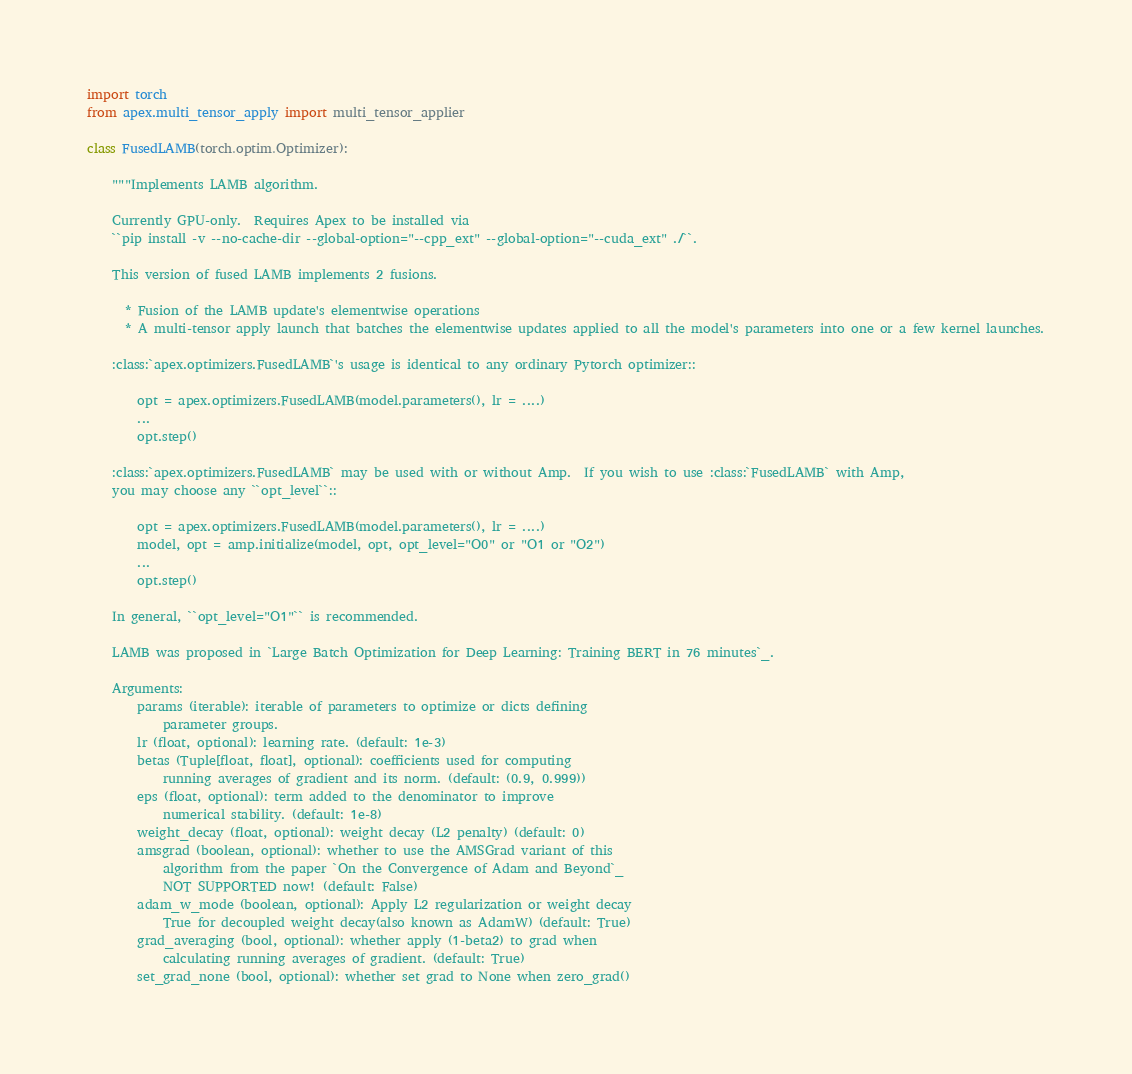<code> <loc_0><loc_0><loc_500><loc_500><_Python_>import torch
from apex.multi_tensor_apply import multi_tensor_applier

class FusedLAMB(torch.optim.Optimizer):

    """Implements LAMB algorithm.

    Currently GPU-only.  Requires Apex to be installed via
    ``pip install -v --no-cache-dir --global-option="--cpp_ext" --global-option="--cuda_ext" ./``.

    This version of fused LAMB implements 2 fusions.

      * Fusion of the LAMB update's elementwise operations
      * A multi-tensor apply launch that batches the elementwise updates applied to all the model's parameters into one or a few kernel launches.

    :class:`apex.optimizers.FusedLAMB`'s usage is identical to any ordinary Pytorch optimizer::

        opt = apex.optimizers.FusedLAMB(model.parameters(), lr = ....)
        ...
        opt.step()

    :class:`apex.optimizers.FusedLAMB` may be used with or without Amp.  If you wish to use :class:`FusedLAMB` with Amp,
    you may choose any ``opt_level``::

        opt = apex.optimizers.FusedLAMB(model.parameters(), lr = ....)
        model, opt = amp.initialize(model, opt, opt_level="O0" or "O1 or "O2")
        ...
        opt.step()

    In general, ``opt_level="O1"`` is recommended.

    LAMB was proposed in `Large Batch Optimization for Deep Learning: Training BERT in 76 minutes`_.

    Arguments:
        params (iterable): iterable of parameters to optimize or dicts defining
            parameter groups.
        lr (float, optional): learning rate. (default: 1e-3)
        betas (Tuple[float, float], optional): coefficients used for computing
            running averages of gradient and its norm. (default: (0.9, 0.999))
        eps (float, optional): term added to the denominator to improve
            numerical stability. (default: 1e-8)
        weight_decay (float, optional): weight decay (L2 penalty) (default: 0)
        amsgrad (boolean, optional): whether to use the AMSGrad variant of this
            algorithm from the paper `On the Convergence of Adam and Beyond`_
            NOT SUPPORTED now! (default: False)
        adam_w_mode (boolean, optional): Apply L2 regularization or weight decay
            True for decoupled weight decay(also known as AdamW) (default: True)
        grad_averaging (bool, optional): whether apply (1-beta2) to grad when
            calculating running averages of gradient. (default: True)
        set_grad_none (bool, optional): whether set grad to None when zero_grad()</code> 